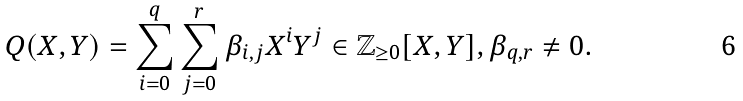<formula> <loc_0><loc_0><loc_500><loc_500>Q ( X , Y ) = \sum _ { i = 0 } ^ { q } \sum _ { j = 0 } ^ { r } \beta _ { i , j } X ^ { i } Y ^ { j } \in \mathbb { Z } _ { \geq 0 } [ X , Y ] , \beta _ { q , r } \neq 0 .</formula> 